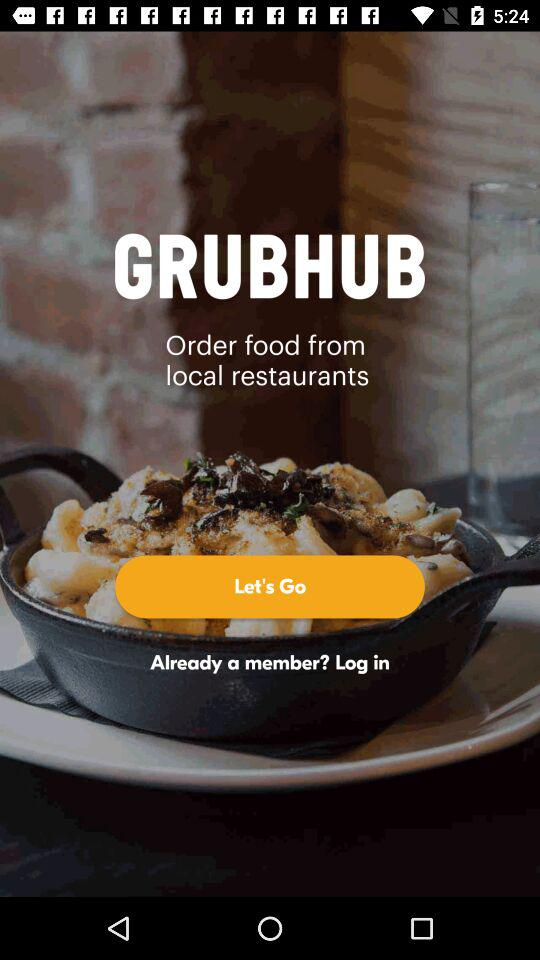Where are the local restaurants?
When the provided information is insufficient, respond with <no answer>. <no answer> 